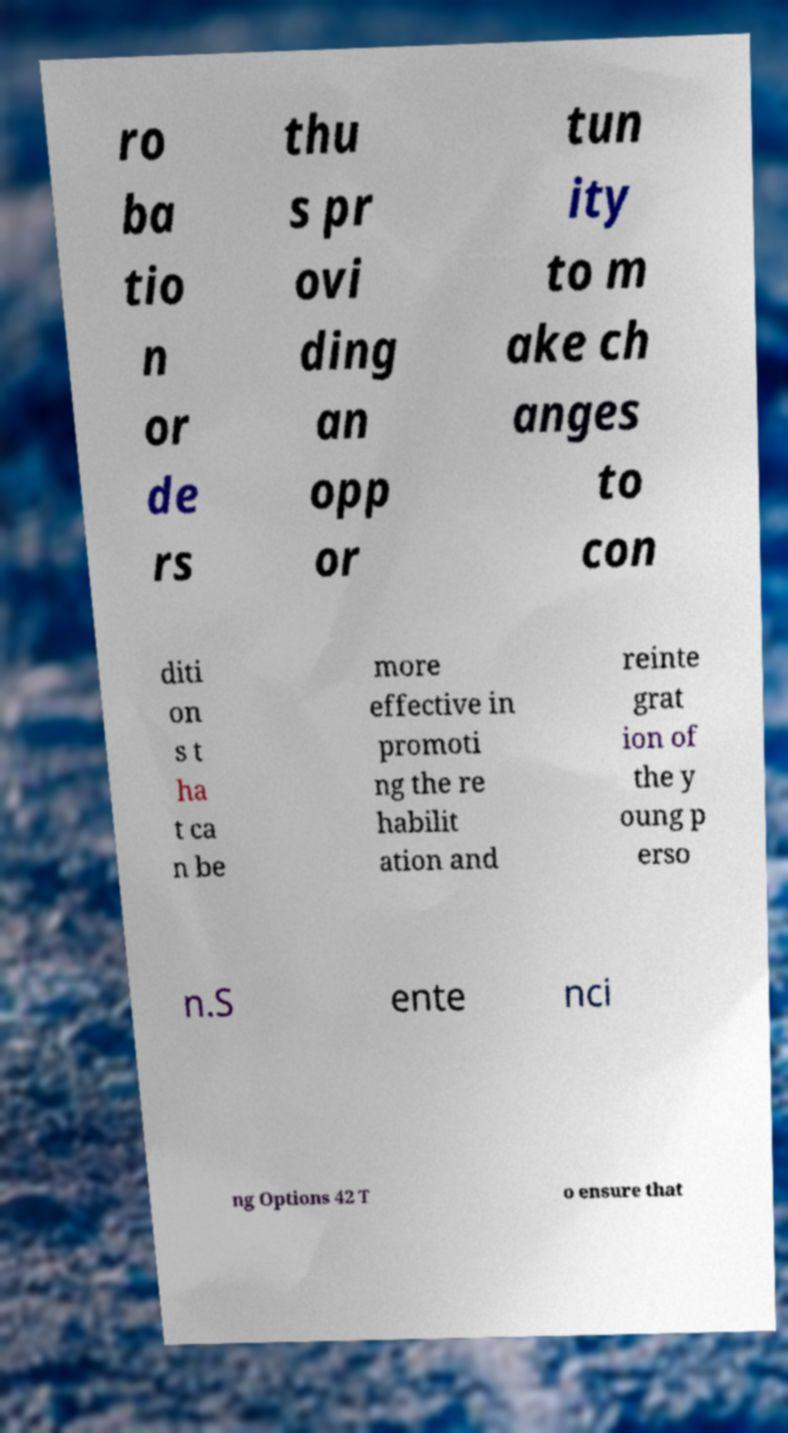Could you assist in decoding the text presented in this image and type it out clearly? ro ba tio n or de rs thu s pr ovi ding an opp or tun ity to m ake ch anges to con diti on s t ha t ca n be more effective in promoti ng the re habilit ation and reinte grat ion of the y oung p erso n.S ente nci ng Options 42 T o ensure that 